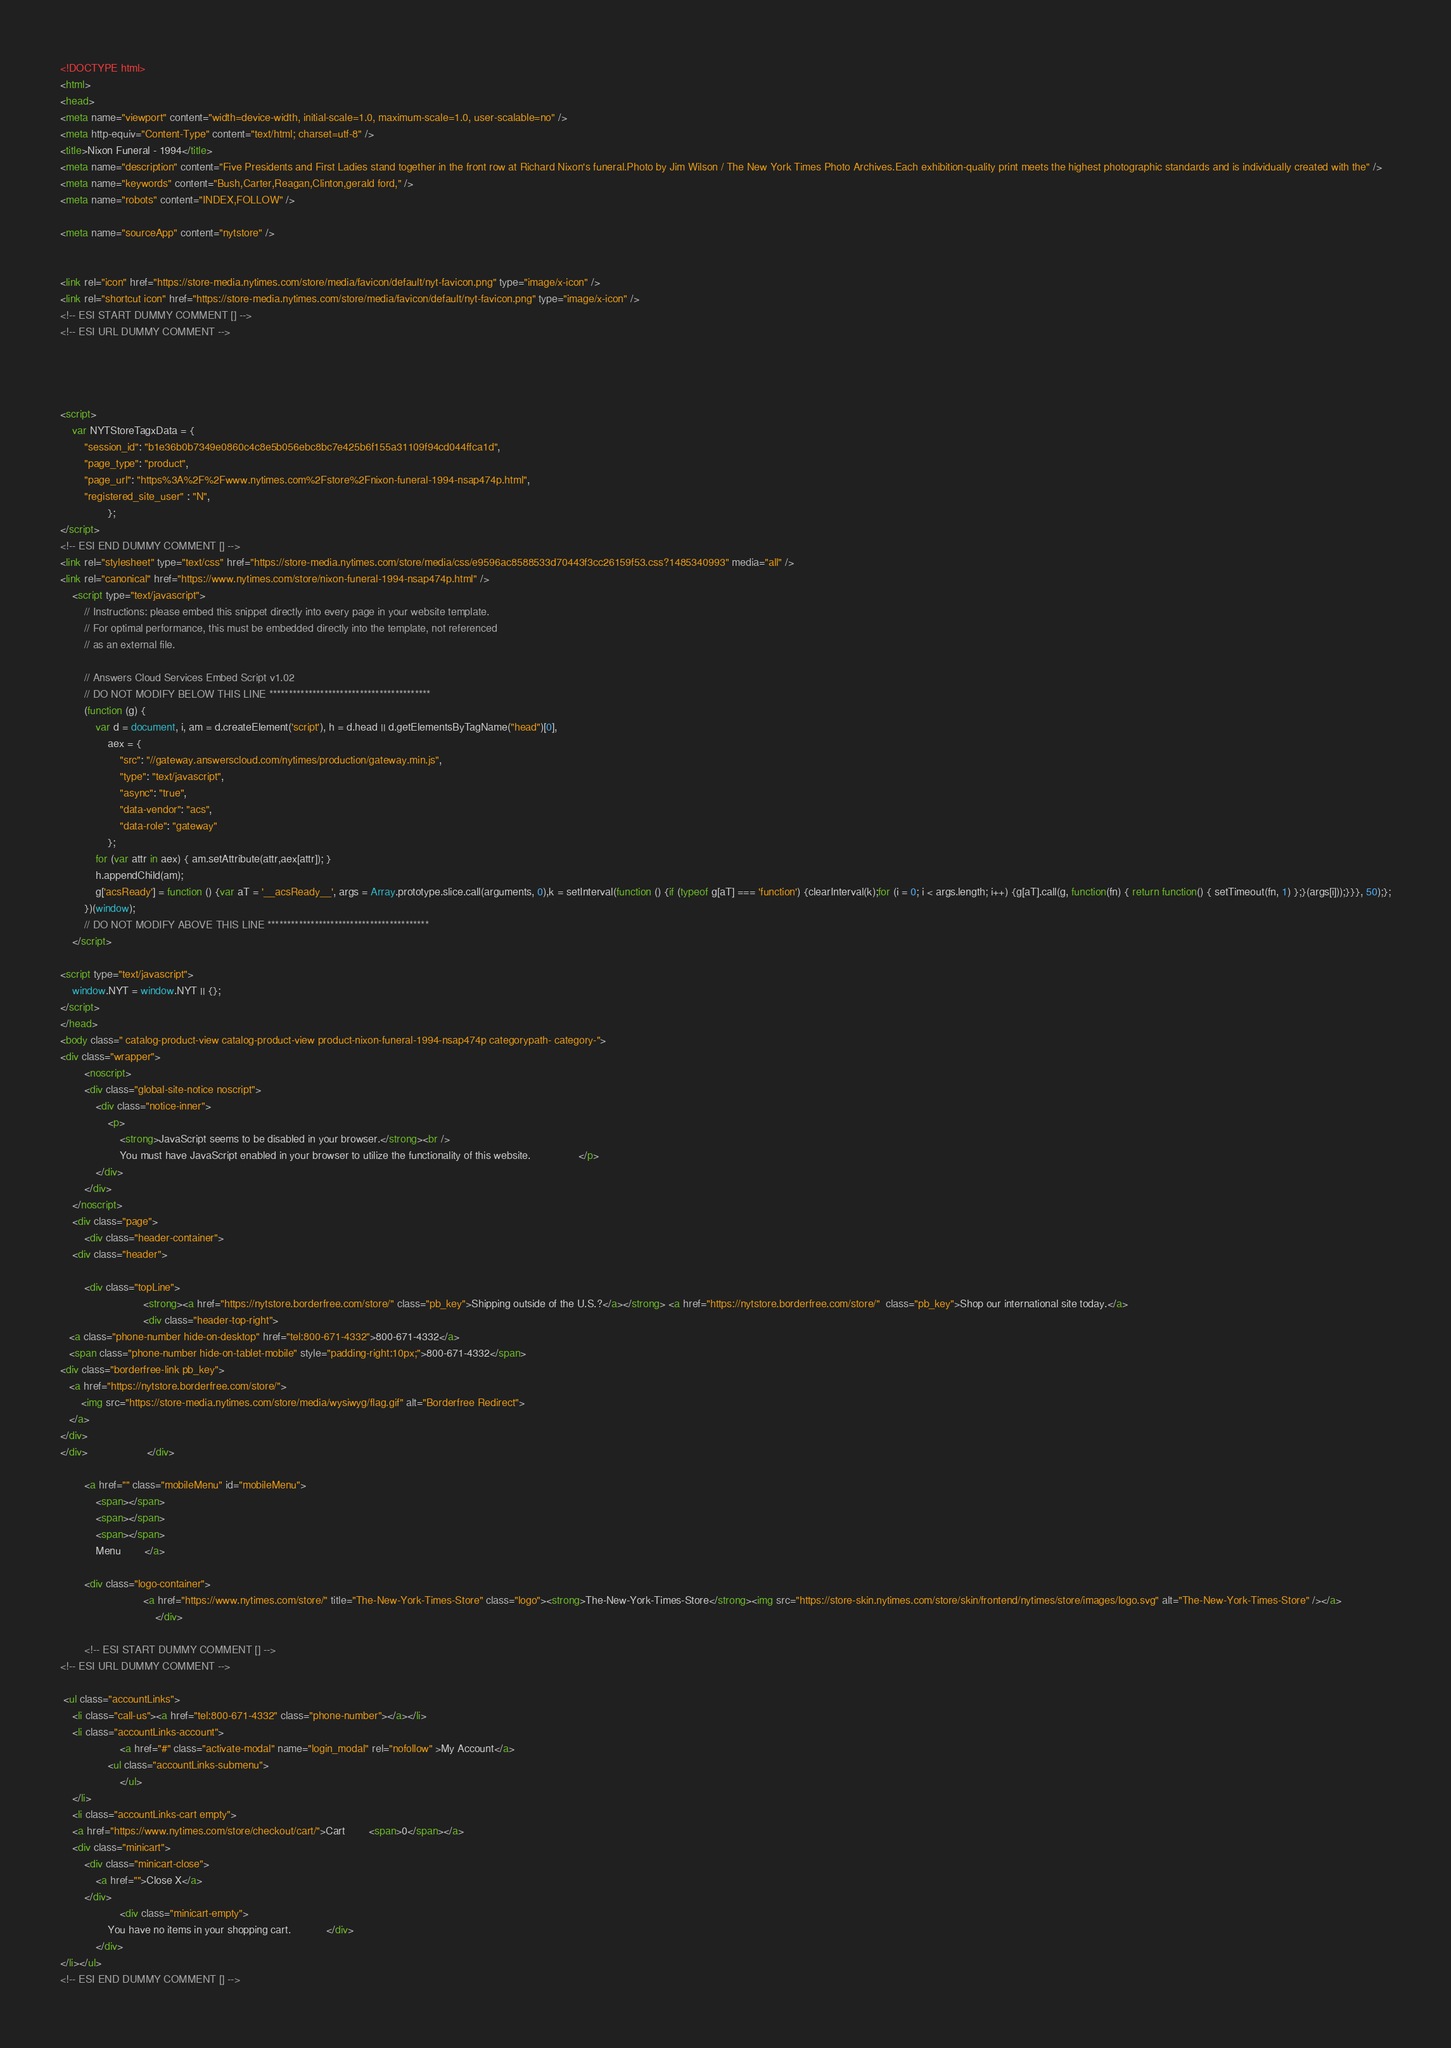<code> <loc_0><loc_0><loc_500><loc_500><_HTML_><!DOCTYPE html>
<html>
<head>
<meta name="viewport" content="width=device-width, initial-scale=1.0, maximum-scale=1.0, user-scalable=no" />
<meta http-equiv="Content-Type" content="text/html; charset=utf-8" />
<title>Nixon Funeral - 1994</title>
<meta name="description" content="Five Presidents and First Ladies stand together in the front row at Richard Nixon's funeral.Photo by Jim Wilson / The New York Times Photo Archives.Each exhibition-quality print meets the highest photographic standards and is individually created with the" />
<meta name="keywords" content="Bush,Carter,Reagan,Clinton,gerald ford," />
<meta name="robots" content="INDEX,FOLLOW" />

<meta name="sourceApp" content="nytstore" />


<link rel="icon" href="https://store-media.nytimes.com/store/media/favicon/default/nyt-favicon.png" type="image/x-icon" />
<link rel="shortcut icon" href="https://store-media.nytimes.com/store/media/favicon/default/nyt-favicon.png" type="image/x-icon" />
<!-- ESI START DUMMY COMMENT [] -->
<!-- ESI URL DUMMY COMMENT -->

 


<script>
    var NYTStoreTagxData = {
        "session_id": "b1e36b0b7349e0860c4c8e5b056ebc8bc7e425b6f155a31109f94cd044ffca1d",
        "page_type": "product",
        "page_url": "https%3A%2F%2Fwww.nytimes.com%2Fstore%2Fnixon-funeral-1994-nsap474p.html",
        "registered_site_user" : "N",
                };
</script> 
<!-- ESI END DUMMY COMMENT [] -->
<link rel="stylesheet" type="text/css" href="https://store-media.nytimes.com/store/media/css/e9596ac8588533d70443f3cc26159f53.css?1485340993" media="all" />
<link rel="canonical" href="https://www.nytimes.com/store/nixon-funeral-1994-nsap474p.html" />
    <script type="text/javascript">
        // Instructions: please embed this snippet directly into every page in your website template.
        // For optimal performance, this must be embedded directly into the template, not referenced
        // as an external file.

        // Answers Cloud Services Embed Script v1.02
        // DO NOT MODIFY BELOW THIS LINE *****************************************
        (function (g) {
            var d = document, i, am = d.createElement('script'), h = d.head || d.getElementsByTagName("head")[0],
                aex = {
                    "src": "//gateway.answerscloud.com/nytimes/production/gateway.min.js",
                    "type": "text/javascript",
                    "async": "true",
                    "data-vendor": "acs",
                    "data-role": "gateway"
                };
            for (var attr in aex) { am.setAttribute(attr,aex[attr]); }
            h.appendChild(am);
            g['acsReady'] = function () {var aT = '__acsReady__', args = Array.prototype.slice.call(arguments, 0),k = setInterval(function () {if (typeof g[aT] === 'function') {clearInterval(k);for (i = 0; i < args.length; i++) {g[aT].call(g, function(fn) { return function() { setTimeout(fn, 1) };}(args[i]));}}}, 50);};
        })(window);
        // DO NOT MODIFY ABOVE THIS LINE *****************************************
    </script>

<script type="text/javascript">
    window.NYT = window.NYT || {};
</script>
</head>
<body class=" catalog-product-view catalog-product-view product-nixon-funeral-1994-nsap474p categorypath- category-">
<div class="wrapper">
        <noscript>
        <div class="global-site-notice noscript">
            <div class="notice-inner">
                <p>
                    <strong>JavaScript seems to be disabled in your browser.</strong><br />
                    You must have JavaScript enabled in your browser to utilize the functionality of this website.                </p>
            </div>
        </div>
    </noscript>
    <div class="page">
        <div class="header-container">
    <div class="header">

        <div class="topLine">
                            <strong><a href="https://nytstore.borderfree.com/store/" class="pb_key">Shipping outside of the U.S.?</a></strong> <a href="https://nytstore.borderfree.com/store/"  class="pb_key">Shop our international site today.</a>             
                            <div class="header-top-right">
   <a class="phone-number hide-on-desktop" href="tel:800-671-4332">800-671-4332</a>
   <span class="phone-number hide-on-tablet-mobile" style="padding-right:10px;">800-671-4332</span>
<div class="borderfree-link pb_key">
   <a href="https://nytstore.borderfree.com/store/">
       <img src="https://store-media.nytimes.com/store/media/wysiwyg/flag.gif" alt="Borderfree Redirect">
   </a>
</div>
</div>                    </div>

        <a href="" class="mobileMenu" id="mobileMenu">
            <span></span>
            <span></span>
            <span></span>
            Menu        </a>

        <div class="logo-container">
                            <a href="https://www.nytimes.com/store/" title="The-New-York-Times-Store" class="logo"><strong>The-New-York-Times-Store</strong><img src="https://store-skin.nytimes.com/store/skin/frontend/nytimes/store/images/logo.svg" alt="The-New-York-Times-Store" /></a>
                                </div>

        <!-- ESI START DUMMY COMMENT [] -->
<!-- ESI URL DUMMY COMMENT -->

 <ul class="accountLinks">
    <li class="call-us"><a href="tel:800-671-4332" class="phone-number"></a></li>
    <li class="accountLinks-account">
                    <a href="#" class="activate-modal" name="login_modal" rel="nofollow" >My Account</a>
                <ul class="accountLinks-submenu">
                    </ul>
    </li>
    <li class="accountLinks-cart empty">
    <a href="https://www.nytimes.com/store/checkout/cart/">Cart        <span>0</span></a>
    <div class="minicart">
        <div class="minicart-close">
            <a href="">Close X</a>
        </div>
                    <div class="minicart-empty">
                You have no items in your shopping cart.            </div>
            </div>
</li></ul> 
<!-- ESI END DUMMY COMMENT [] --></code> 